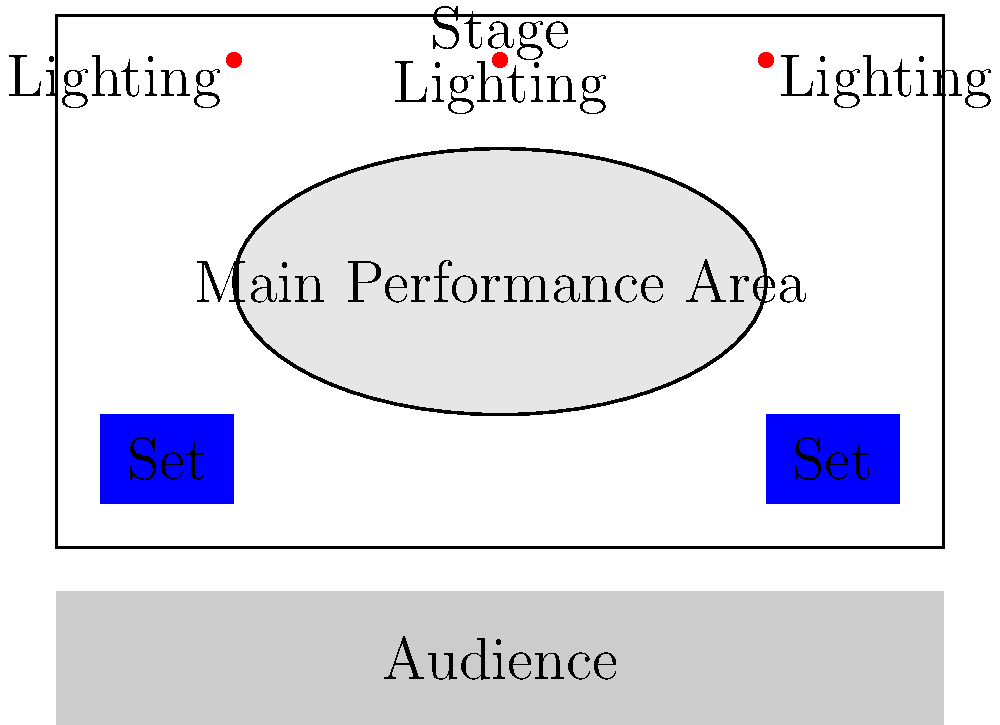Given the stage layout shown, which arrangement of performers would best utilize the space and lighting for a musical performance featuring a lead singer, backup vocalist, guitarist, bassist, and drummer? To determine the most effective arrangement, we need to consider several factors:

1. Visibility: The lead singer should be prominent and easily visible to the audience.
2. Lighting: The performers should be positioned to take advantage of the three lighting positions.
3. Space utilization: The arrangement should make efficient use of the main performance area.
4. Set integration: The performers should be positioned in a way that incorporates the set pieces.

Step-by-step arrangement:

1. Lead singer: Place at the center front of the main performance area, directly under the central lighting position. This ensures maximum visibility and optimal lighting.

2. Backup vocalist: Position slightly behind and to one side of the lead singer, allowing them to harmonize visually and vocally while still being well-lit.

3. Guitarist: Place to the opposite side of the backup vocalist, forming a triangular formation with the lead singer. This balances the stage and allows for interaction between musicians.

4. Bassist: Position behind the guitarist, closer to one of the side lighting positions. This adds depth to the stage arrangement while ensuring good lighting.

5. Drummer: Place at the rear of the main performance area, centered between the two set pieces. This provides a solid backdrop for the other performers and allows the drummer to be seen by the audience.

This arrangement creates a dynamic, tiered formation that maximizes visibility, utilizes all lighting positions, and integrates the set pieces into the overall stage picture. It also allows for easy movement and interaction between performers, enhancing the musical storytelling aspect of the performance.
Answer: Lead singer center front, backup vocalist and guitarist flanking, bassist behind guitarist, drummer at rear center. 